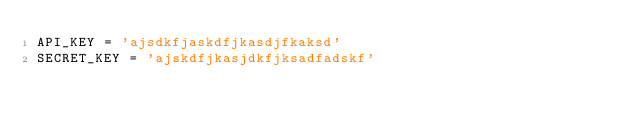<code> <loc_0><loc_0><loc_500><loc_500><_Python_>API_KEY = 'ajsdkfjaskdfjkasdjfkaksd'
SECRET_KEY = 'ajskdfjkasjdkfjksadfadskf'
</code> 